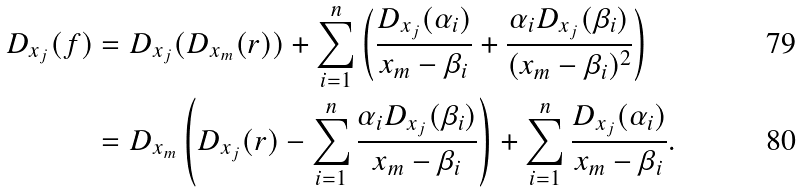Convert formula to latex. <formula><loc_0><loc_0><loc_500><loc_500>D _ { x _ { j } } ( f ) & = D _ { x _ { j } } ( D _ { x _ { m } } ( r ) ) + \sum _ { i = 1 } ^ { n } \left ( \frac { D _ { x _ { j } } ( \alpha _ { i } ) } { { x _ { m } } - \beta _ { i } } + \frac { \alpha _ { i } D _ { x _ { j } } ( \beta _ { i } ) } { ( { x _ { m } } - \beta _ { i } ) ^ { 2 } } \right ) \\ & = D _ { x _ { m } } \left ( D _ { x _ { j } } ( r ) - \sum _ { i = 1 } ^ { n } \frac { \alpha _ { i } D _ { x _ { j } } ( \beta _ { i } ) } { { x _ { m } } - \beta _ { i } } \right ) + \sum _ { i = 1 } ^ { n } \frac { D _ { x _ { j } } ( \alpha _ { i } ) } { { x _ { m } } - \beta _ { i } } .</formula> 